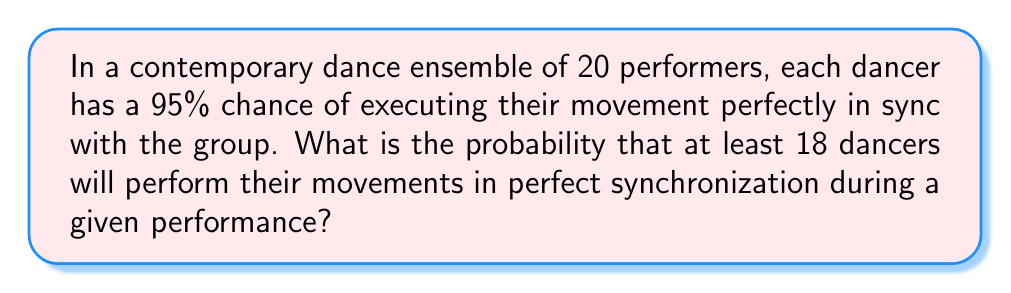Could you help me with this problem? Let's approach this step-by-step using the binomial probability distribution:

1) We can model this as a binomial distribution where:
   $n = 20$ (total number of dancers)
   $p = 0.95$ (probability of perfect synchronization for each dancer)
   $X$ = number of dancers in perfect sync

2) We want to find $P(X \geq 18)$

3) This is equivalent to:
   $P(X \geq 18) = 1 - P(X < 18) = 1 - P(X \leq 17)$

4) Using the binomial probability formula:
   $$P(X = k) = \binom{n}{k} p^k (1-p)^{n-k}$$

5) We need to calculate:
   $$1 - [P(X = 17) + P(X = 16) + P(X = 15) + ... + P(X = 0)]$$

6) Let's use the cumulative binomial probability function:
   $$P(X \geq 18) = 1 - \sum_{k=0}^{17} \binom{20}{k} (0.95)^k (0.05)^{20-k}$$

7) Using a calculator or computer (as this involves complex calculations):
   $$P(X \geq 18) \approx 0.9845$$

Therefore, the probability that at least 18 dancers will perform their movements in perfect synchronization is approximately 0.9845 or 98.45%.
Answer: $0.9845$ or $98.45\%$ 